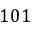<formula> <loc_0><loc_0><loc_500><loc_500>1 0 1</formula> 